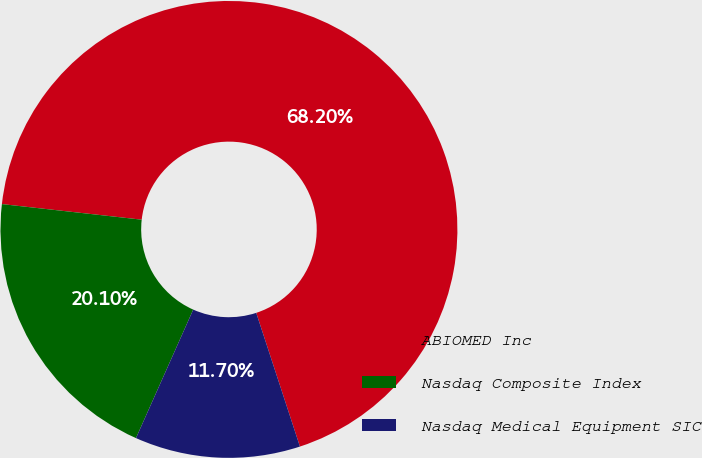Convert chart. <chart><loc_0><loc_0><loc_500><loc_500><pie_chart><fcel>ABIOMED Inc<fcel>Nasdaq Composite Index<fcel>Nasdaq Medical Equipment SIC<nl><fcel>68.21%<fcel>20.1%<fcel>11.7%<nl></chart> 